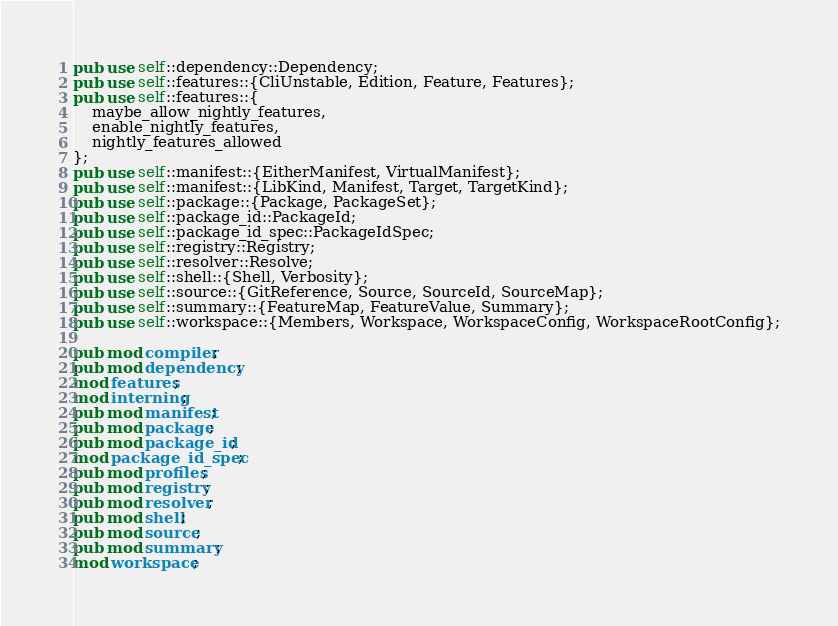Convert code to text. <code><loc_0><loc_0><loc_500><loc_500><_Rust_>pub use self::dependency::Dependency;
pub use self::features::{CliUnstable, Edition, Feature, Features};
pub use self::features::{
    maybe_allow_nightly_features,
    enable_nightly_features,
    nightly_features_allowed
};
pub use self::manifest::{EitherManifest, VirtualManifest};
pub use self::manifest::{LibKind, Manifest, Target, TargetKind};
pub use self::package::{Package, PackageSet};
pub use self::package_id::PackageId;
pub use self::package_id_spec::PackageIdSpec;
pub use self::registry::Registry;
pub use self::resolver::Resolve;
pub use self::shell::{Shell, Verbosity};
pub use self::source::{GitReference, Source, SourceId, SourceMap};
pub use self::summary::{FeatureMap, FeatureValue, Summary};
pub use self::workspace::{Members, Workspace, WorkspaceConfig, WorkspaceRootConfig};

pub mod compiler;
pub mod dependency;
mod features;
mod interning;
pub mod manifest;
pub mod package;
pub mod package_id;
mod package_id_spec;
pub mod profiles;
pub mod registry;
pub mod resolver;
pub mod shell;
pub mod source;
pub mod summary;
mod workspace;
</code> 